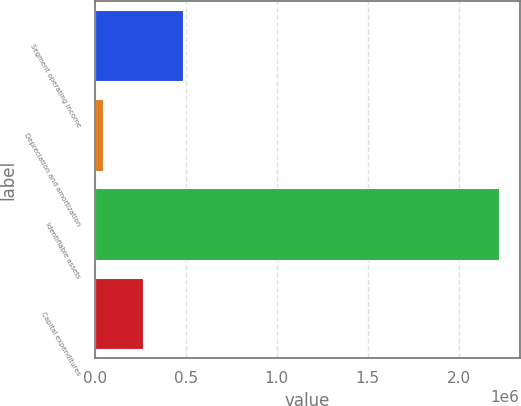Convert chart. <chart><loc_0><loc_0><loc_500><loc_500><bar_chart><fcel>Segment operating income<fcel>Depreciation and amortization<fcel>Identifiable assets<fcel>Capital expenditures<nl><fcel>483164<fcel>48007<fcel>2.22379e+06<fcel>265585<nl></chart> 